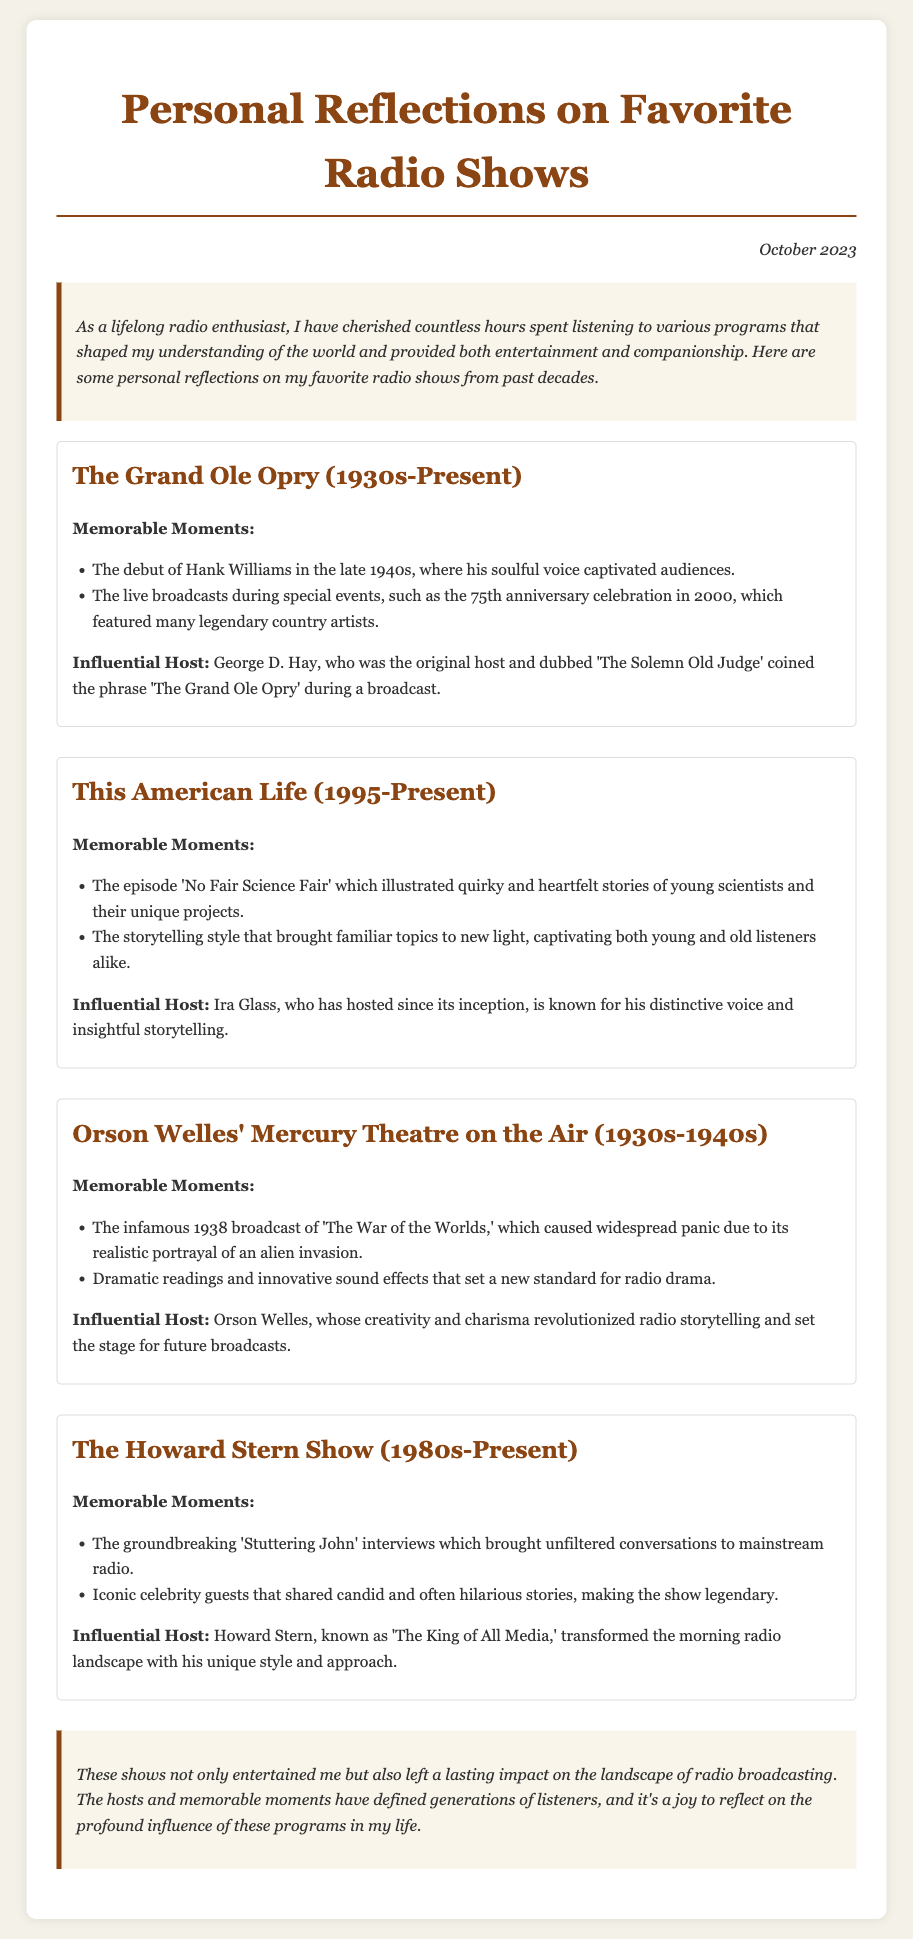what is the title of the memo? The title of the memo is displayed prominently at the top of the document.
Answer: Personal Reflections on Favorite Radio Shows who is one influential host of 'This American Life'? This information can be found in the section discussing the show 'This American Life'.
Answer: Ira Glass what notable event occurred in 1938 related to Orson Welles? The document mentions a specific broadcast that caused a significant reaction, indicating its importance.
Answer: 'The War of the Worlds' what decade did 'The Grand Ole Opry' begin? The beginning decade for the show 'The Grand Ole Opry' is stated in the memo.
Answer: 1930s how long has 'The Howard Stern Show' been on air? The duration of the show is provided in the title information.
Answer: 1980s-Present which episode of 'This American Life' is mentioned in the memo? A notable episode is cited along with its theme, showing its significance.
Answer: 'No Fair Science Fair' what type of moments are listed for 'The Howard Stern Show'? The memorable occurrences are categorized under memorable moments in the document.
Answer: Groundbreaking interviews what is the conclusion about the impact of these radio shows? The conclusion summarizes the general sentiment and significance of the shows discussed.
Answer: Lasting impact on the landscape of radio broadcasting 